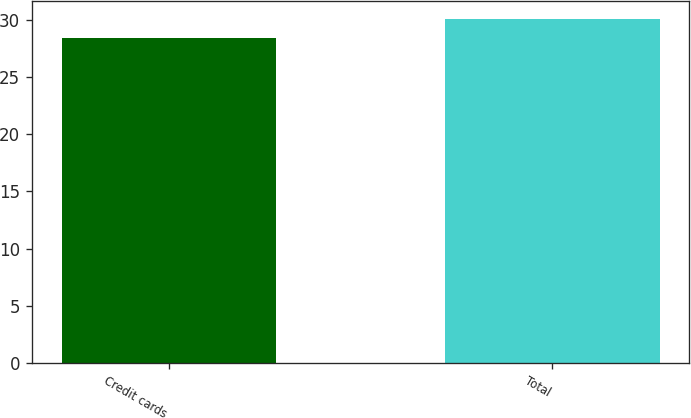<chart> <loc_0><loc_0><loc_500><loc_500><bar_chart><fcel>Credit cards<fcel>Total<nl><fcel>28.4<fcel>30.1<nl></chart> 